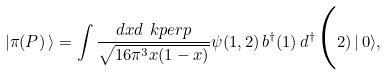Convert formula to latex. <formula><loc_0><loc_0><loc_500><loc_500>| \pi ( P ) \, \rangle = \int \frac { d x d \ k p e r p } { \sqrt { 1 6 \pi ^ { 3 } x ( 1 - x ) } } \psi ( 1 , 2 ) \, b ^ { \dagger } ( 1 ) \, d ^ { \dagger } \Big ( 2 ) \, | \, 0 \rangle ,</formula> 